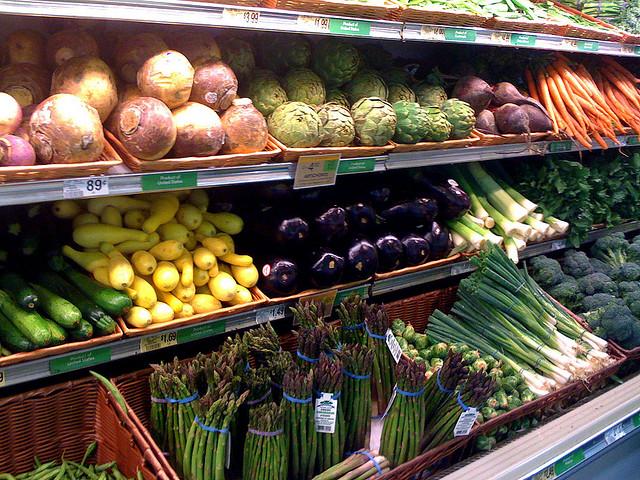Is this at a store?
Short answer required. Yes. Is the produce fresh?
Write a very short answer. Yes. Are there any dates?
Answer briefly. No. How many vegetables are in the picture?
Answer briefly. 14. 